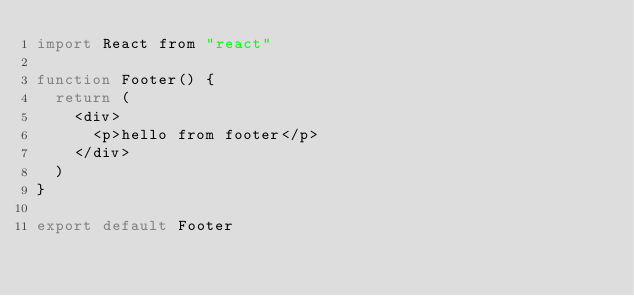Convert code to text. <code><loc_0><loc_0><loc_500><loc_500><_JavaScript_>import React from "react"

function Footer() {
  return (
    <div>
      <p>hello from footer</p>
    </div>
  )
}

export default Footer
</code> 